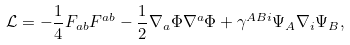<formula> <loc_0><loc_0><loc_500><loc_500>\mathcal { L } = - \frac { 1 } { 4 } F _ { a b } F ^ { a b } - \frac { 1 } { 2 } \nabla _ { a } \Phi \nabla ^ { a } \Phi + \gamma ^ { A B i } \Psi _ { A } \nabla _ { i } \Psi _ { B } ,</formula> 